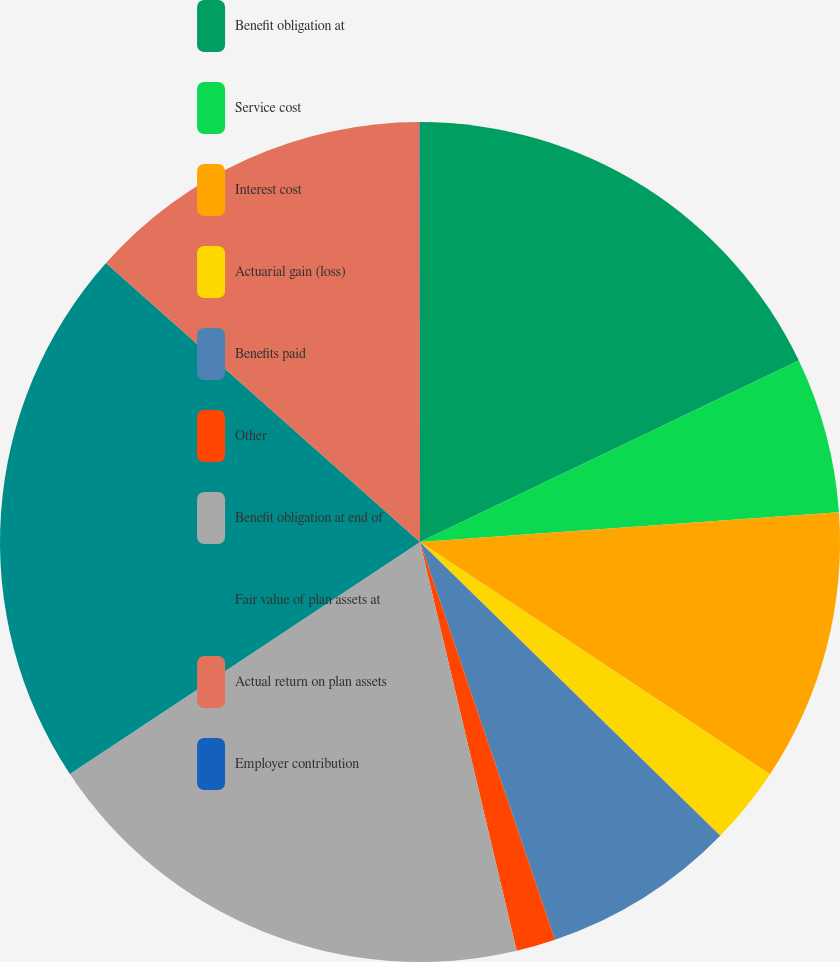<chart> <loc_0><loc_0><loc_500><loc_500><pie_chart><fcel>Benefit obligation at<fcel>Service cost<fcel>Interest cost<fcel>Actuarial gain (loss)<fcel>Benefits paid<fcel>Other<fcel>Benefit obligation at end of<fcel>Fair value of plan assets at<fcel>Actual return on plan assets<fcel>Employer contribution<nl><fcel>17.89%<fcel>5.98%<fcel>10.45%<fcel>3.0%<fcel>7.47%<fcel>1.51%<fcel>19.38%<fcel>20.87%<fcel>13.42%<fcel>0.02%<nl></chart> 